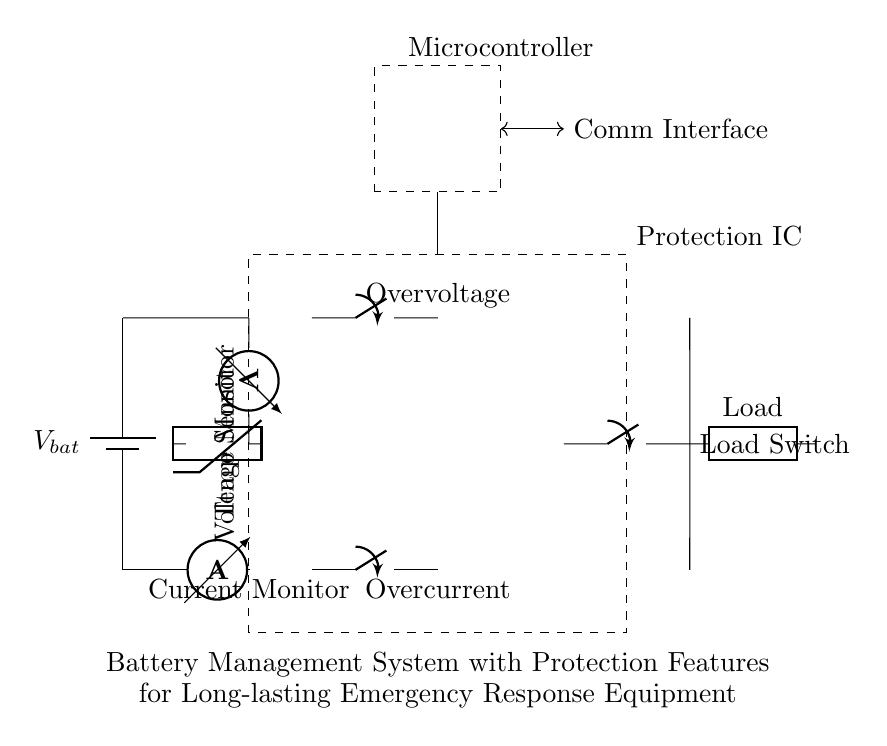What is the primary power source in this circuit? The primary power source is the battery, as indicated by the battery symbol at the left side of the diagram.
Answer: Battery What component is used for current monitoring? The component used for current monitoring is the ammeter, which is denoted at the bottom of the protection IC section.
Answer: Ammeter Which device monitors the temperature? The temperature in the circuit is monitored by a thermistor, shown in the circuit connected near the battery and protection IC.
Answer: Thermistor What type of protection is applied for overcurrent? Overcurrent protection in the circuit is implemented using a closing switch, which is specifically marked as an Overcurrent switch, allowing circuit interruption when excessive current flows.
Answer: Closing switch How many protection features are there in this circuit? There are three protection features clearly identified in the circuit: Overcurrent, Overvoltage, and load control, indicated by their corresponding switches.
Answer: Three What is the purpose of the microcontroller in this circuit? The microcontroller manages the operation of the battery management system, including control and monitoring functions, as highlighted by its labeled box above in the diagram.
Answer: Management What connection facilitates communication in the circuit? Communication is facilitated by a dedicated communication interface indicated by a double-headed arrow connecting the microcontroller to the protection IC section.
Answer: Comm Interface 